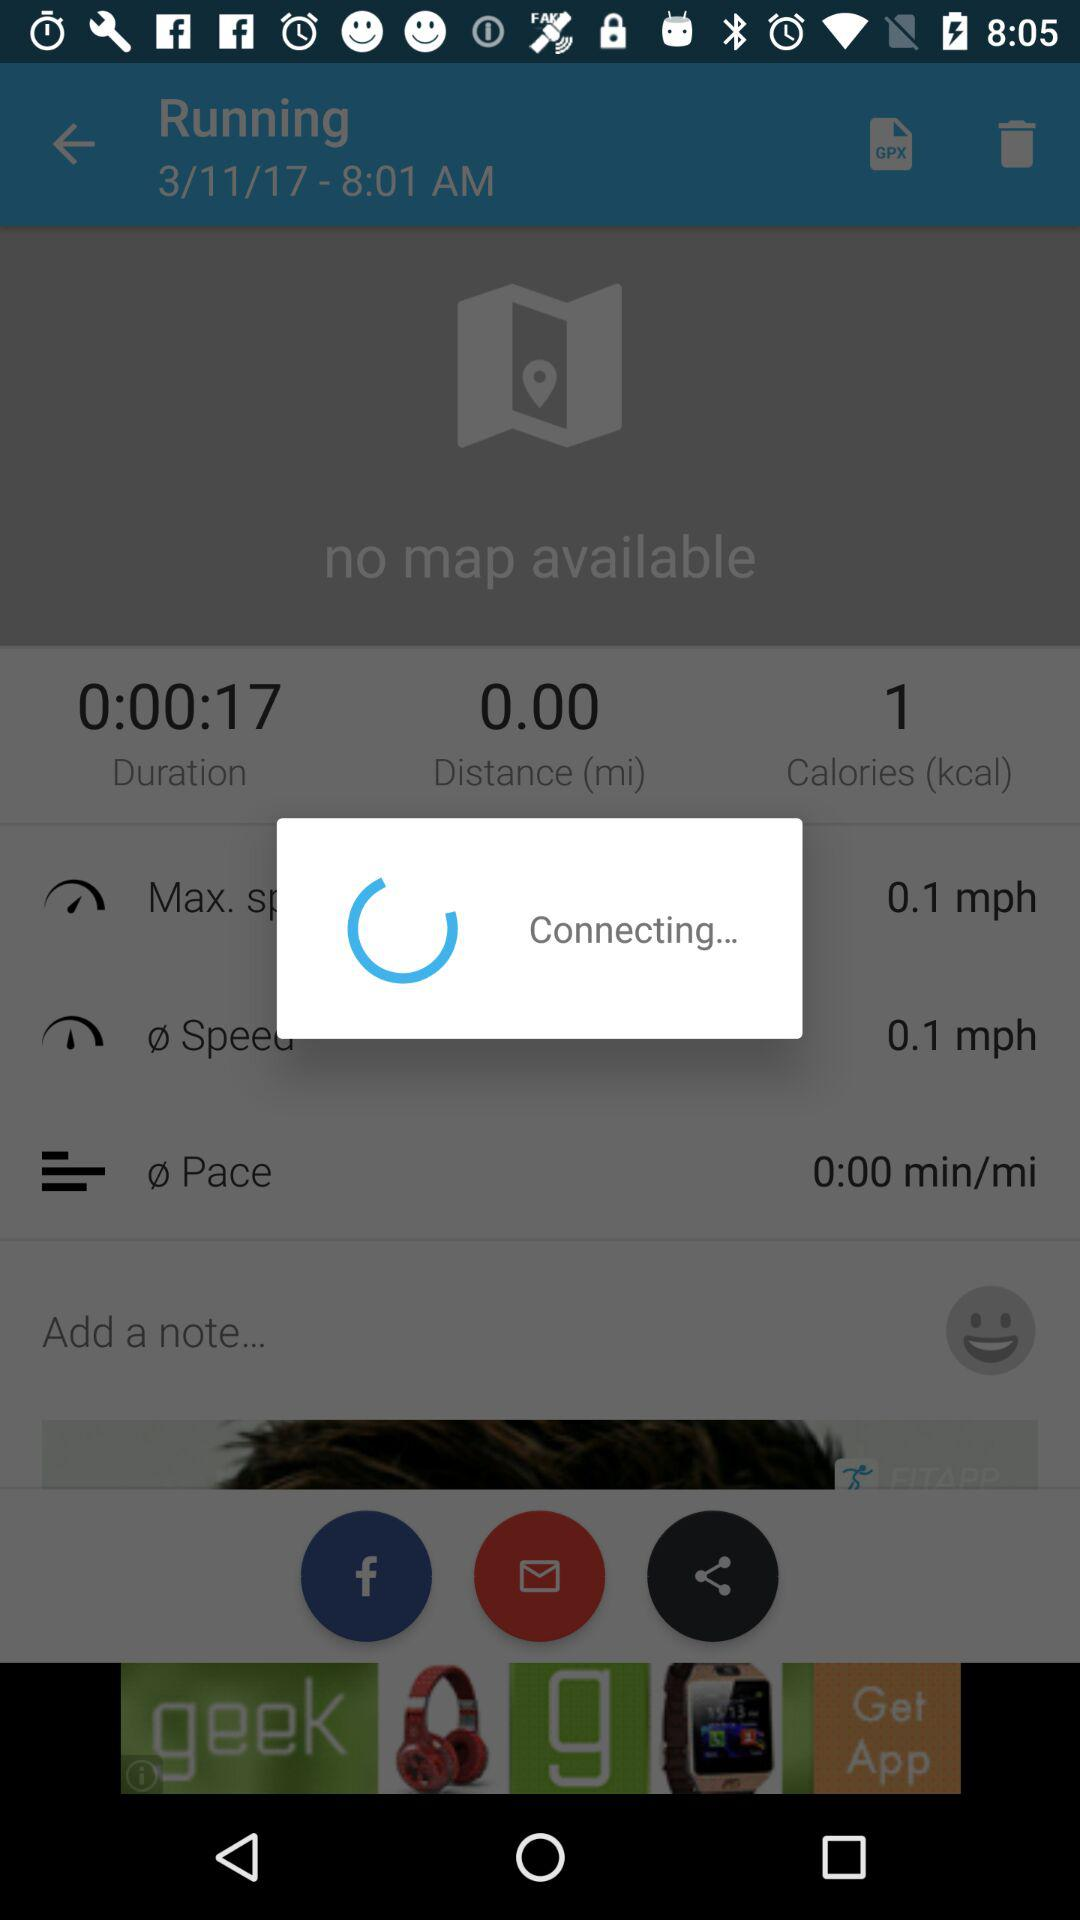What is the duration? The duration is 16 seconds. 